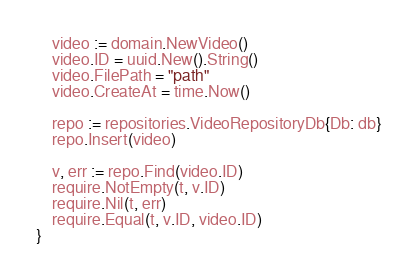<code> <loc_0><loc_0><loc_500><loc_500><_Go_>
	video := domain.NewVideo()
	video.ID = uuid.New().String()
	video.FilePath = "path"
	video.CreateAt = time.Now()

	repo := repositories.VideoRepositoryDb{Db: db}
	repo.Insert(video)

	v, err := repo.Find(video.ID)
	require.NotEmpty(t, v.ID)
	require.Nil(t, err)
	require.Equal(t, v.ID, video.ID)
}
</code> 